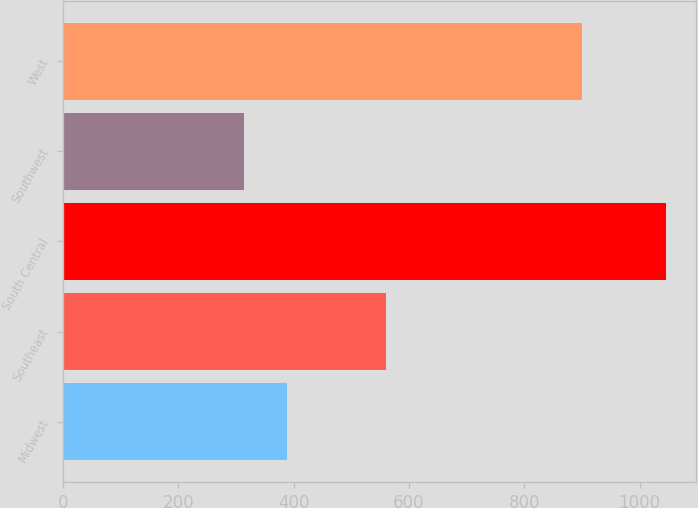<chart> <loc_0><loc_0><loc_500><loc_500><bar_chart><fcel>Midwest<fcel>Southeast<fcel>South Central<fcel>Southwest<fcel>West<nl><fcel>388<fcel>560.8<fcel>1045.9<fcel>314.9<fcel>899.6<nl></chart> 